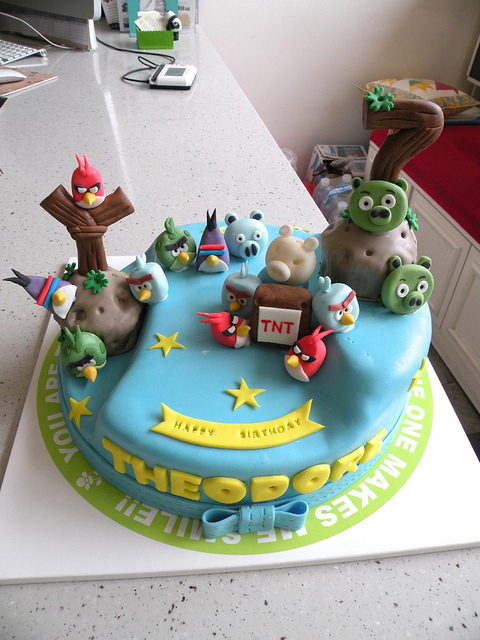Identify the text contained in this image. TNT HAPPY BIRTHDAY THEODO YOU SMILE!! ONE MAKES 